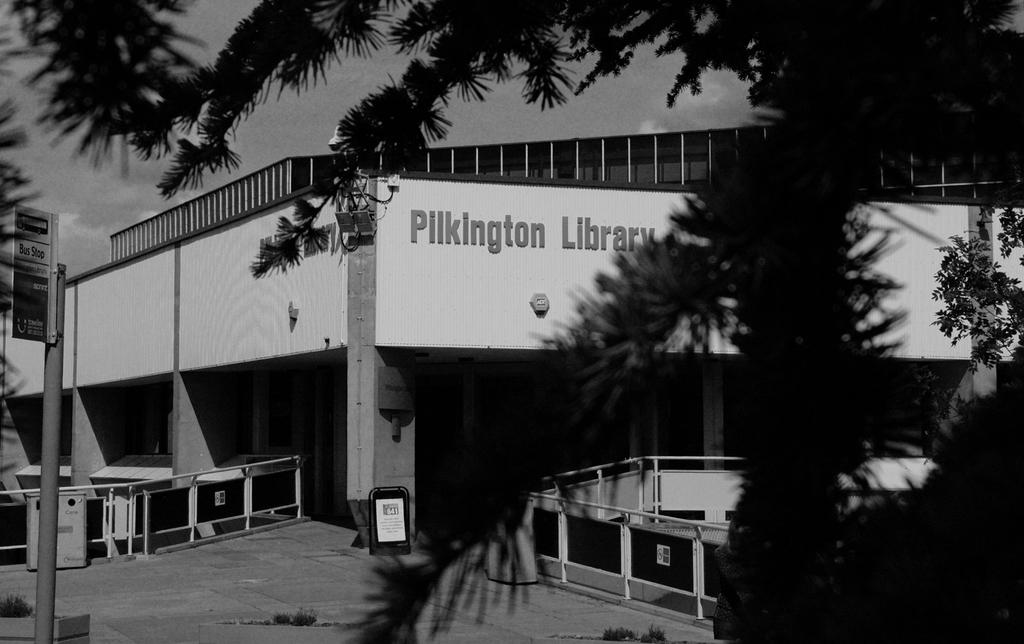What type of vegetation is visible in the front of the image? There are trees in the front of the image. What can be seen on the left side of the image? There is a board on the left side of the image. What type of structure is present in the image? There are fences in the image. What is located at the back of the image? There is a building at the back of the image. What is visible at the top of the image? The sky is visible at the top of the image. How is the image presented in terms of color? The image is in black and white. What type of rule is being enforced by the trees in the image? There is no rule being enforced by the trees in the image; they are simply a type of vegetation. Can you see any volleyball players or equipment in the image? There is no volleyball or volleyball players present in the image. 